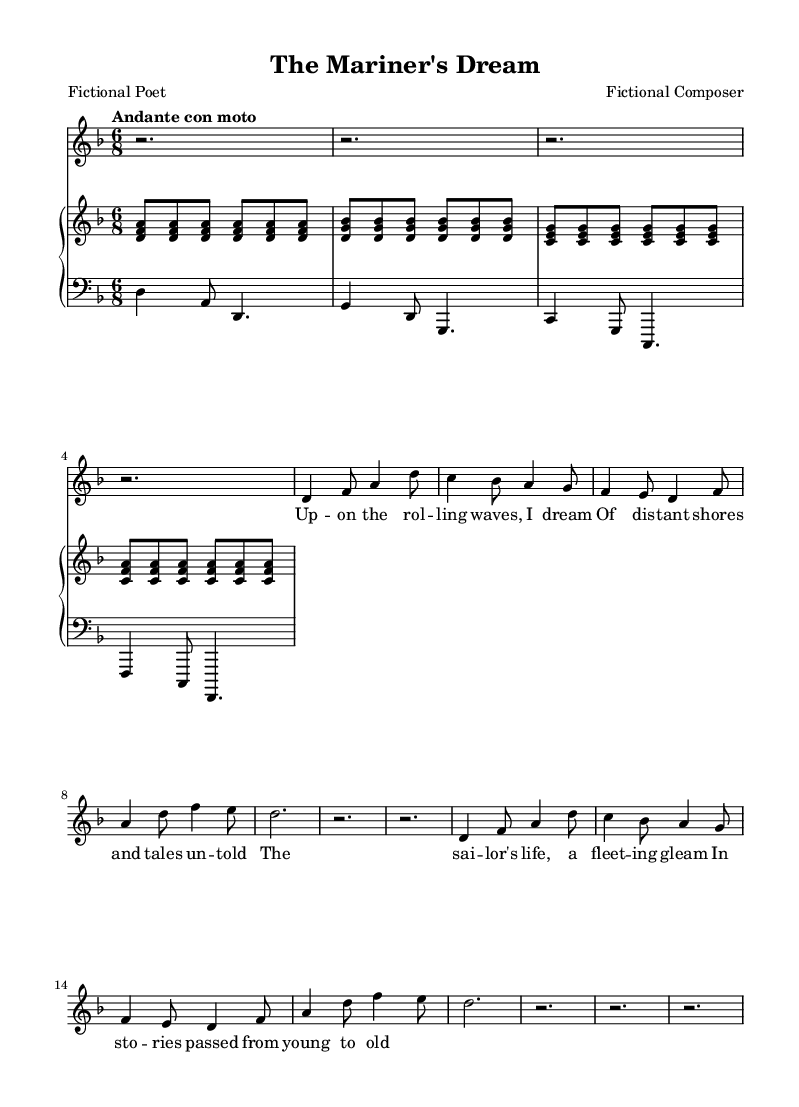What is the key signature of this music? The key signature is identified by the presence of two flats (B flat and E flat), which indicates that the piece is set in D minor.
Answer: D minor What is the time signature of this music? The time signature is shown at the beginning of the staff and is represented by the fraction "6/8," indicating it has six eighth-note beats per measure.
Answer: 6/8 What is the tempo marking of the piece? The tempo marking appears at the beginning and states "Andante con moto," which suggests a moderately slow tempo with some movement.
Answer: Andante con moto Which musical form does this piece likely represent? By examining the structured sections, we see that the song includes a melody with lyrics, characteristic of a Romantic art song. This form emphasizes lyricism and emotional expression, common in this genre.
Answer: Art song How many measures are present in the melody? Counting the number of measures from the beginning to the end of the melody segment indicates there are eight distinct measures present in the melodic line.
Answer: Eight What is the highest note in the melody? By scrutinizing the melody line, the highest note observed is "a4," which is indicated in the treble clef throughout the piece.
Answer: A4 What is the overall mood suggested by the lyrics? The lyrics focus on dreams of distant shores and the sailor's life, evoking a reflective and nostalgic mood typical of Romantic poetry. Thus, the mood can be described as contemplative.
Answer: Contemplative 